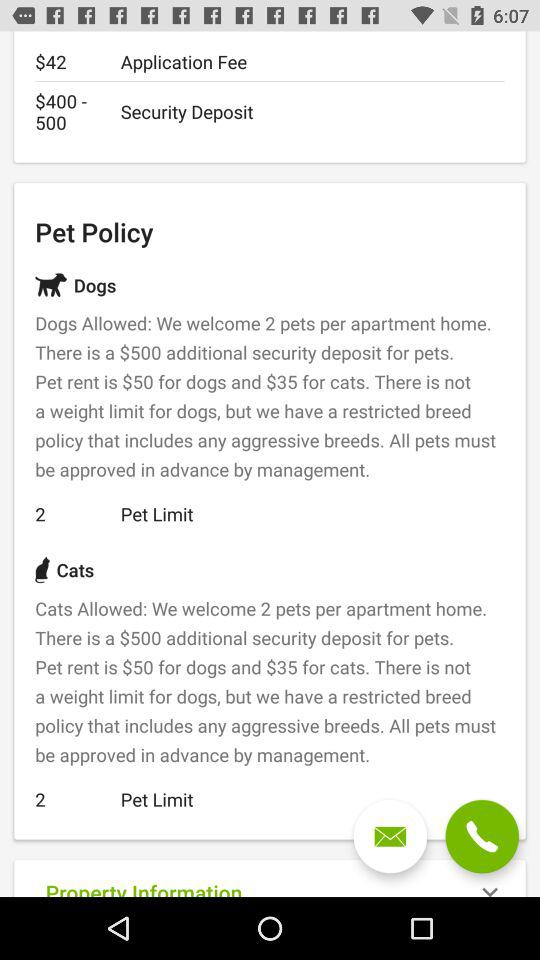What is the security deposit for pets? The security deposit for pets is $500. 